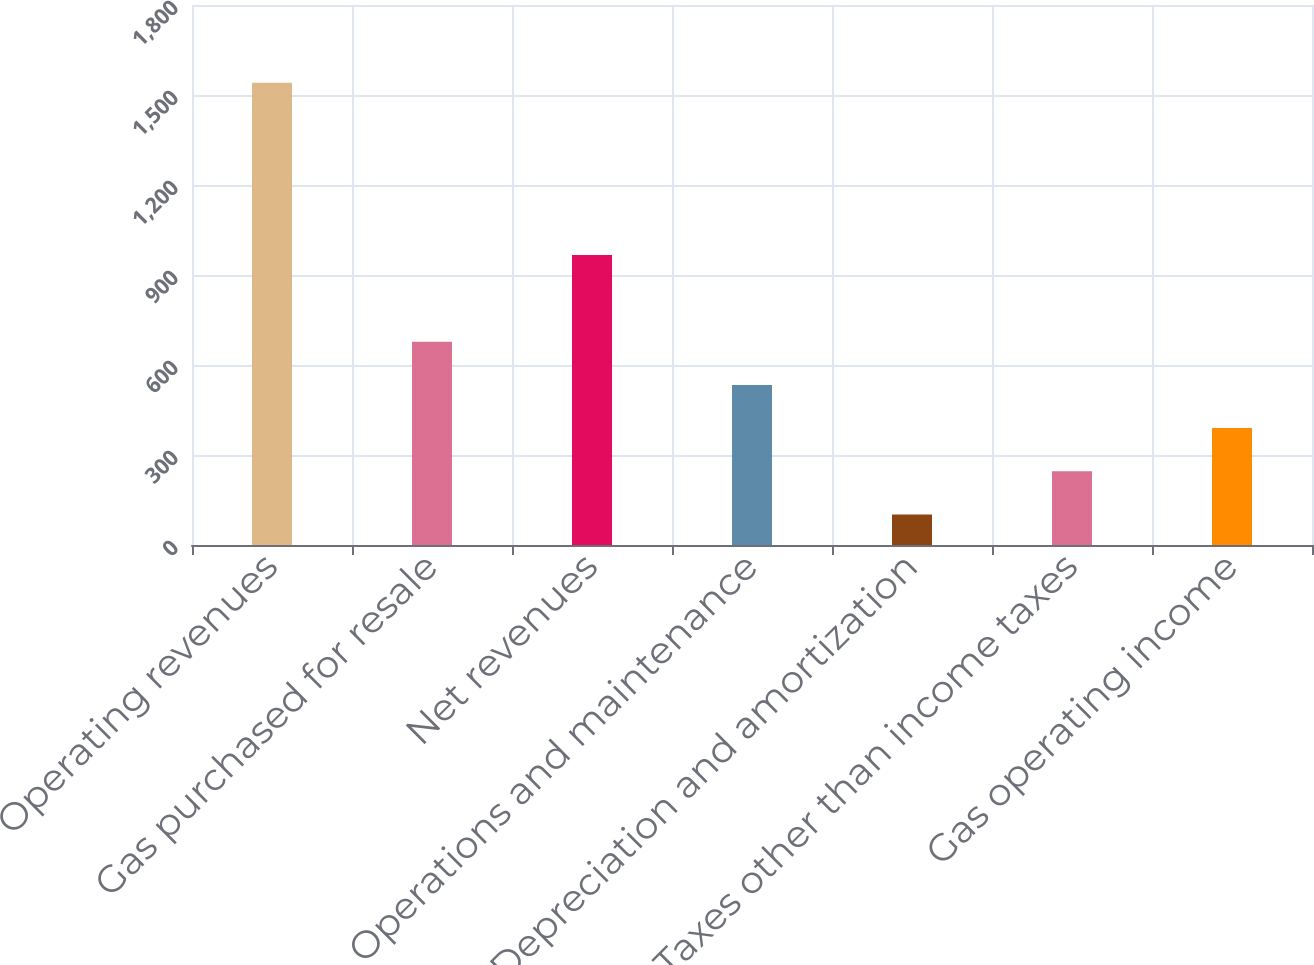Convert chart. <chart><loc_0><loc_0><loc_500><loc_500><bar_chart><fcel>Operating revenues<fcel>Gas purchased for resale<fcel>Net revenues<fcel>Operations and maintenance<fcel>Depreciation and amortization<fcel>Taxes other than income taxes<fcel>Gas operating income<nl><fcel>1541<fcel>677.6<fcel>967<fcel>533.7<fcel>102<fcel>245.9<fcel>389.8<nl></chart> 